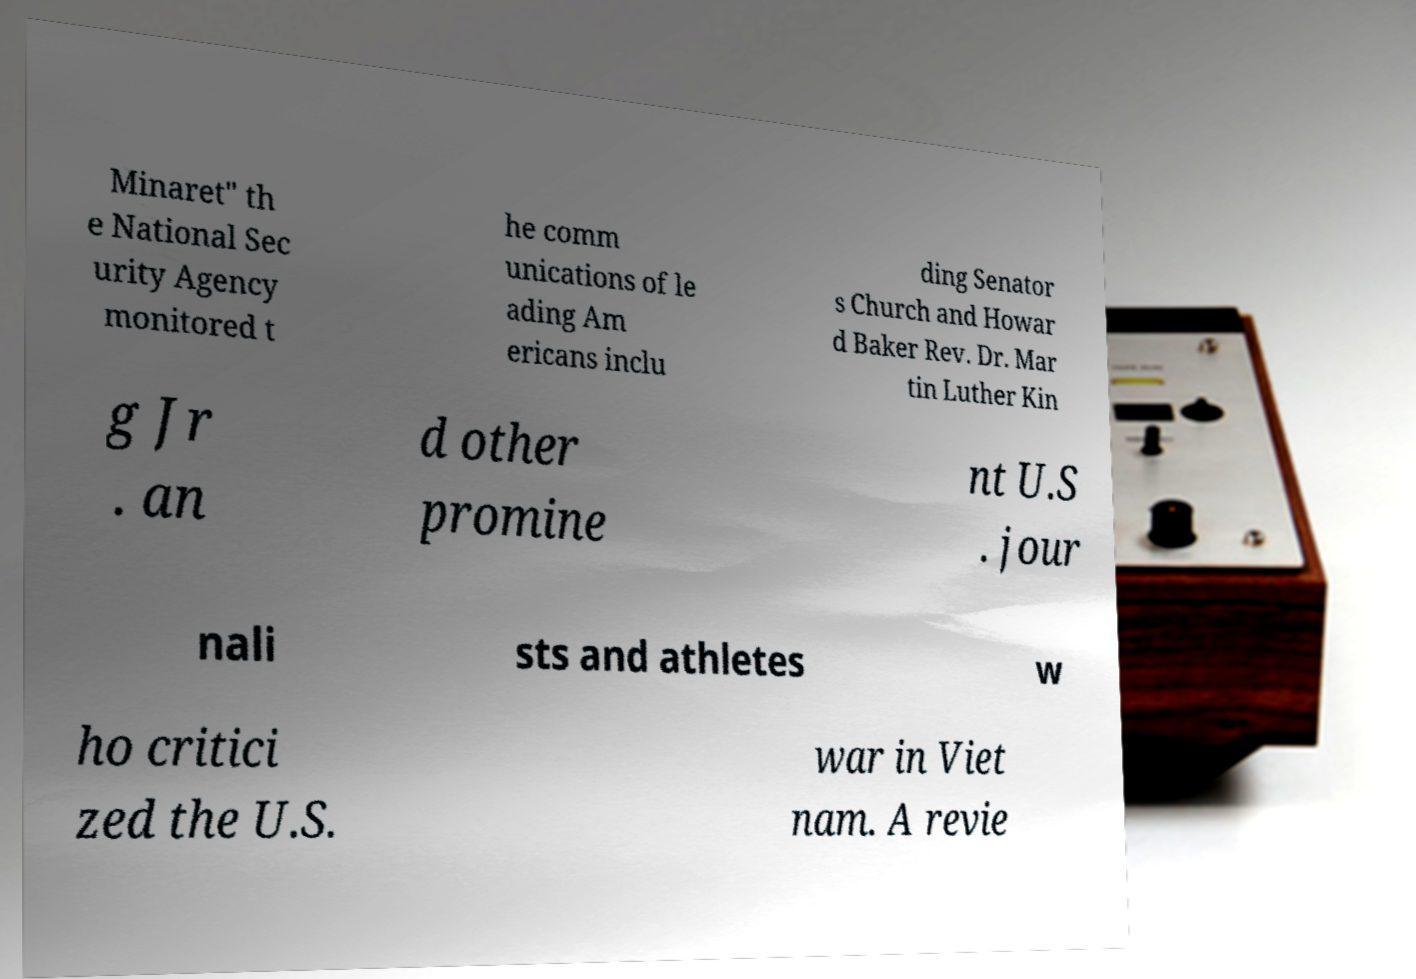Can you accurately transcribe the text from the provided image for me? Minaret" th e National Sec urity Agency monitored t he comm unications of le ading Am ericans inclu ding Senator s Church and Howar d Baker Rev. Dr. Mar tin Luther Kin g Jr . an d other promine nt U.S . jour nali sts and athletes w ho critici zed the U.S. war in Viet nam. A revie 